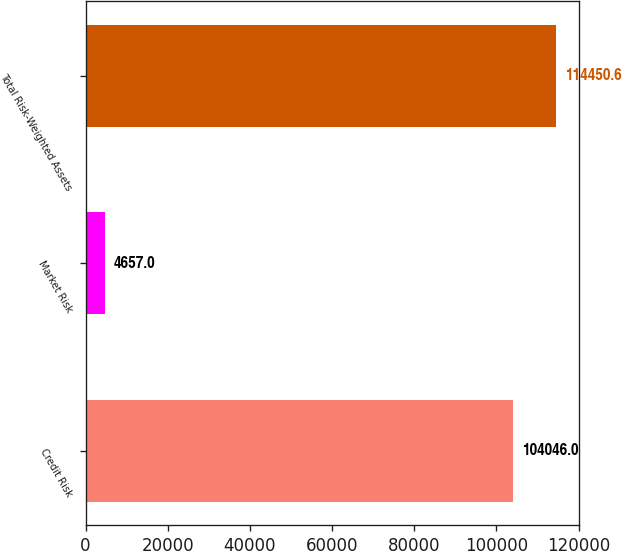Convert chart. <chart><loc_0><loc_0><loc_500><loc_500><bar_chart><fcel>Credit Risk<fcel>Market Risk<fcel>Total Risk-Weighted Assets<nl><fcel>104046<fcel>4657<fcel>114451<nl></chart> 